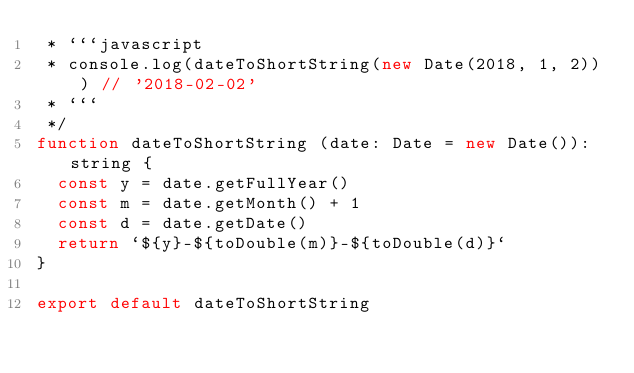Convert code to text. <code><loc_0><loc_0><loc_500><loc_500><_JavaScript_> * ```javascript
 * console.log(dateToShortString(new Date(2018, 1, 2))) // '2018-02-02'
 * ```
 */
function dateToShortString (date: Date = new Date()): string {
  const y = date.getFullYear()
  const m = date.getMonth() + 1
  const d = date.getDate()
  return `${y}-${toDouble(m)}-${toDouble(d)}`
}

export default dateToShortString
</code> 